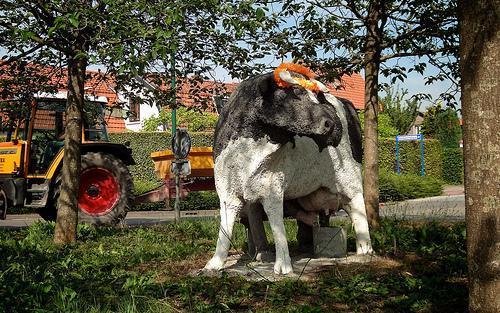How many animals are in the photo?
Give a very brief answer. 1. How many eyes are shown in this picture?
Give a very brief answer. 1. How many wheels on the tractor are visible?
Give a very brief answer. 1. 